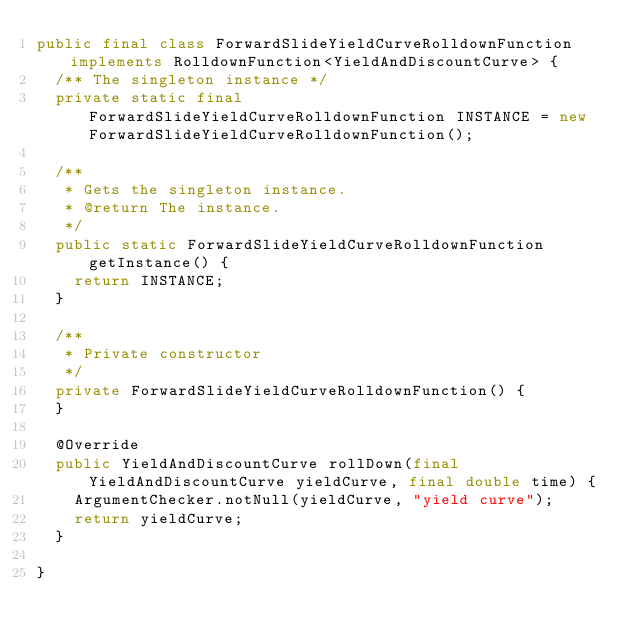<code> <loc_0><loc_0><loc_500><loc_500><_Java_>public final class ForwardSlideYieldCurveRolldownFunction implements RolldownFunction<YieldAndDiscountCurve> {
  /** The singleton instance */
  private static final ForwardSlideYieldCurveRolldownFunction INSTANCE = new ForwardSlideYieldCurveRolldownFunction();

  /**
   * Gets the singleton instance.
   * @return The instance.
   */
  public static ForwardSlideYieldCurveRolldownFunction getInstance() {
    return INSTANCE;
  }

  /**
   * Private constructor
   */
  private ForwardSlideYieldCurveRolldownFunction() {
  }

  @Override
  public YieldAndDiscountCurve rollDown(final YieldAndDiscountCurve yieldCurve, final double time) {
    ArgumentChecker.notNull(yieldCurve, "yield curve");
    return yieldCurve;
  }

}
</code> 